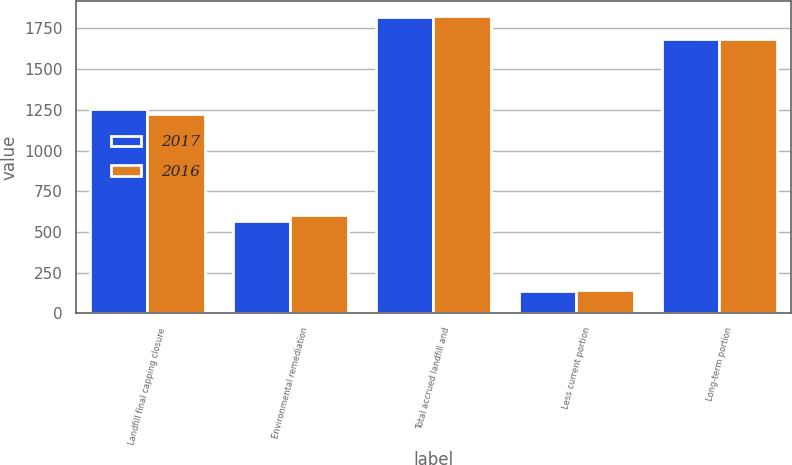Convert chart to OTSL. <chart><loc_0><loc_0><loc_500><loc_500><stacked_bar_chart><ecel><fcel>Landfill final capping closure<fcel>Environmental remediation<fcel>Total accrued landfill and<fcel>Less current portion<fcel>Long-term portion<nl><fcel>2017<fcel>1257.7<fcel>564<fcel>1821.7<fcel>135.2<fcel>1686.5<nl><fcel>2016<fcel>1224.6<fcel>602.9<fcel>1827.5<fcel>142.7<fcel>1684.8<nl></chart> 